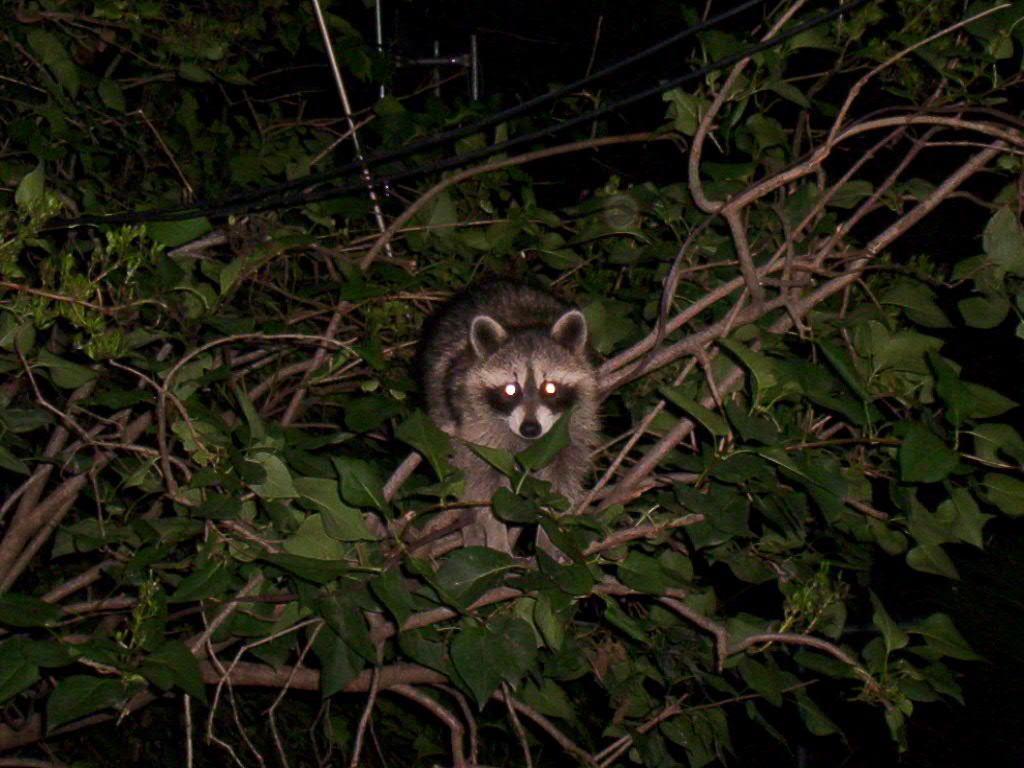What type of animal is in the image? The animal in the image is not specified, but it is present on a tree. Where is the animal located in the image? The animal is on a tree. What features does the tree have? The tree has branches and leaves. How many friends does the animal have in the image? The number of friends the animal has is not mentioned in the image, as there is no information about other animals or people present. What type of drum can be seen in the image? There is no drum present in the image; it only features an animal on a tree with branches and leaves. 